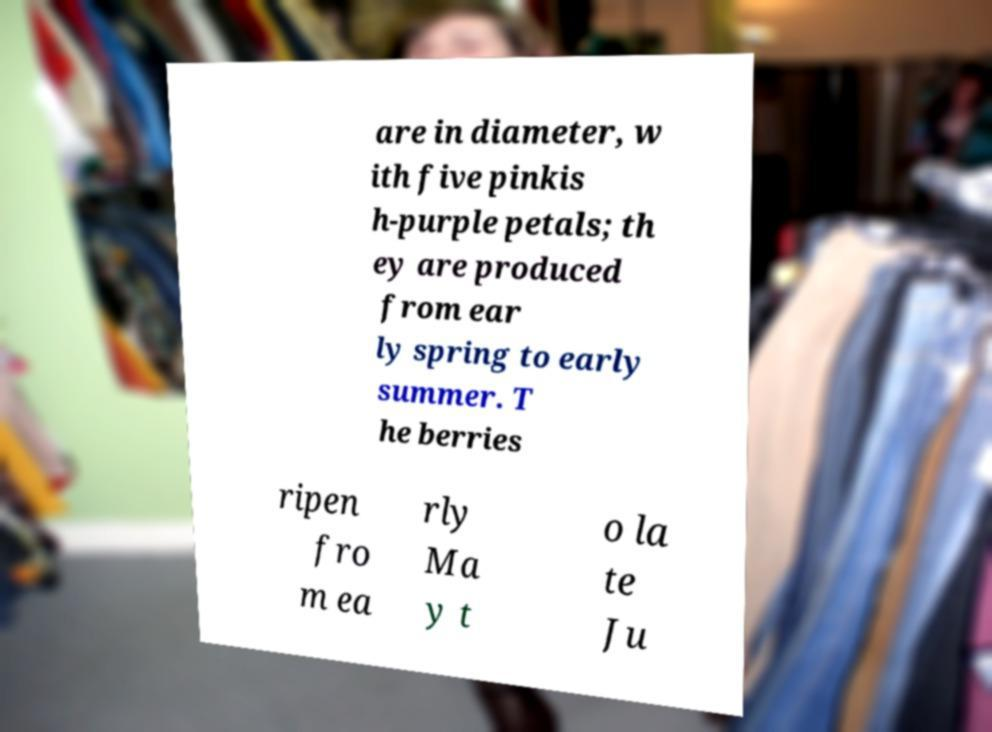Please identify and transcribe the text found in this image. are in diameter, w ith five pinkis h-purple petals; th ey are produced from ear ly spring to early summer. T he berries ripen fro m ea rly Ma y t o la te Ju 